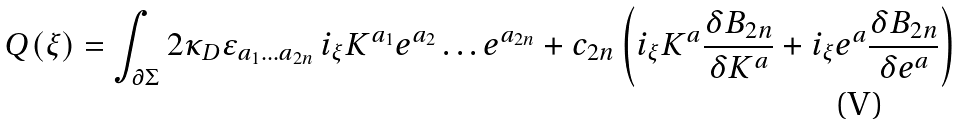<formula> <loc_0><loc_0><loc_500><loc_500>Q ( \xi ) = \int _ { \partial \Sigma } 2 \kappa _ { D } \varepsilon _ { a _ { 1 } \dots a _ { 2 n } } \, i _ { \xi } K ^ { a _ { 1 } } e ^ { a _ { 2 } } \dots e ^ { a _ { 2 n } } + c _ { 2 n } \left ( i _ { \xi } K ^ { a } \frac { \delta B _ { 2 n } } { \delta K ^ { a } } + i _ { \xi } e ^ { a } \frac { \delta B _ { 2 n } } { \delta e ^ { a } } \right )</formula> 